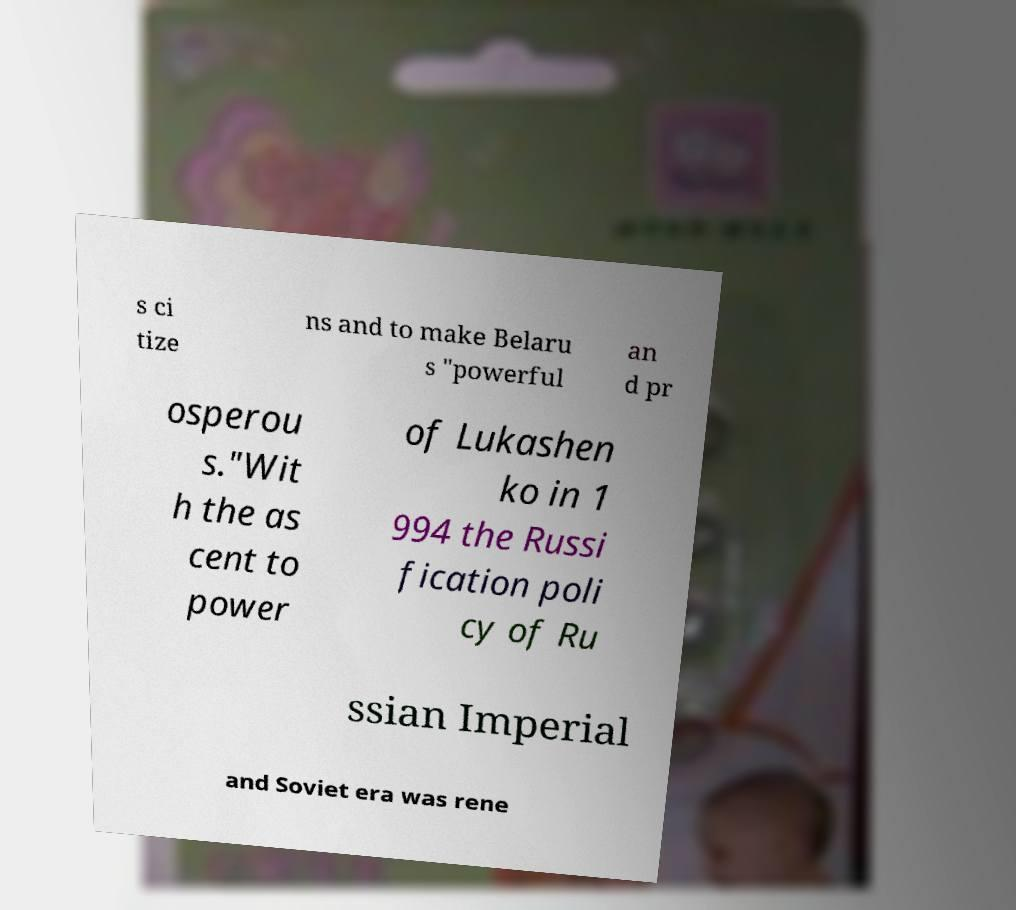Can you read and provide the text displayed in the image?This photo seems to have some interesting text. Can you extract and type it out for me? s ci tize ns and to make Belaru s "powerful an d pr osperou s."Wit h the as cent to power of Lukashen ko in 1 994 the Russi fication poli cy of Ru ssian Imperial and Soviet era was rene 